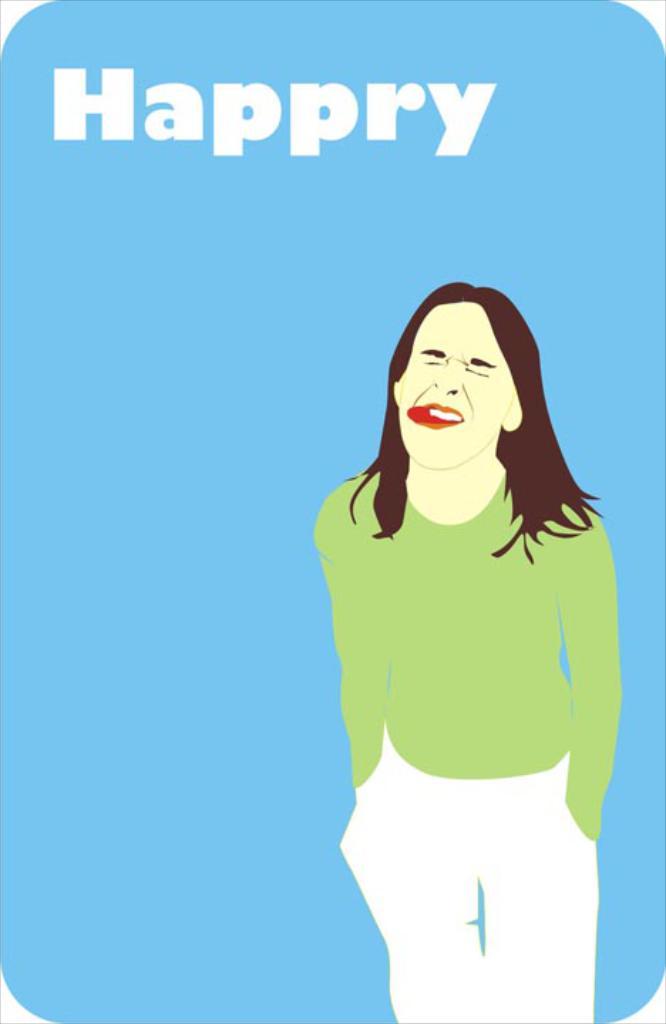What letter has been added to happy?
Provide a short and direct response. R. What does this say?
Give a very brief answer. Happry. 